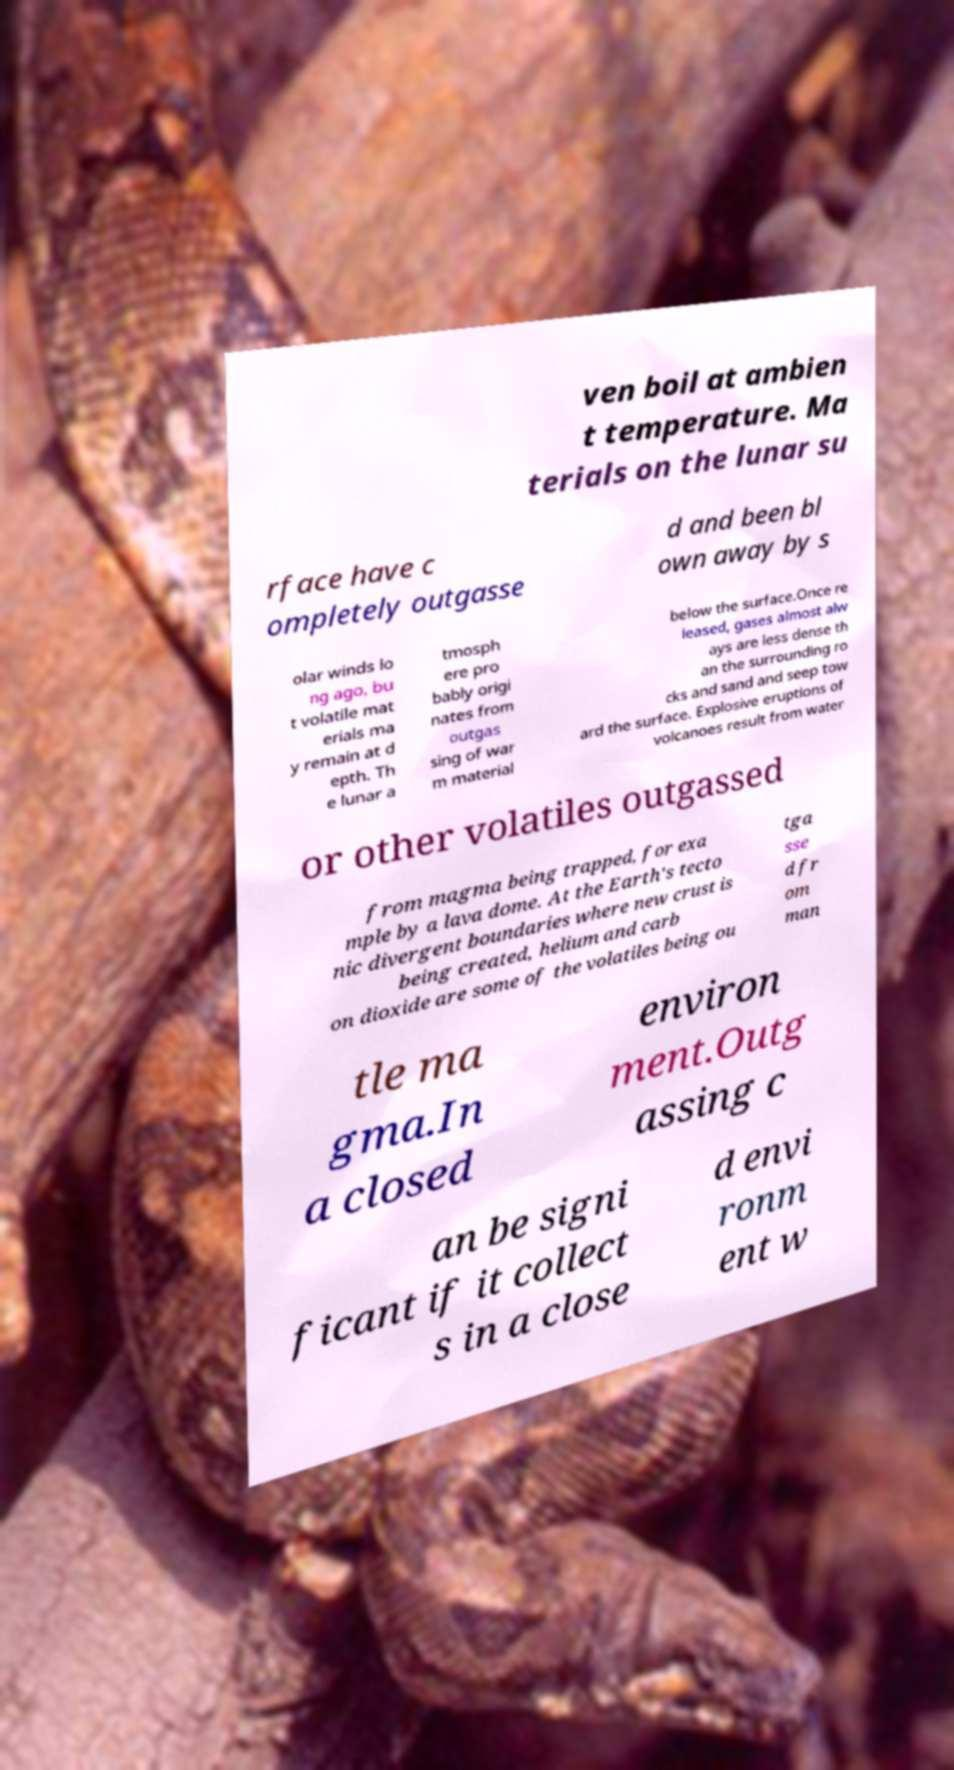I need the written content from this picture converted into text. Can you do that? ven boil at ambien t temperature. Ma terials on the lunar su rface have c ompletely outgasse d and been bl own away by s olar winds lo ng ago, bu t volatile mat erials ma y remain at d epth. Th e lunar a tmosph ere pro bably origi nates from outgas sing of war m material below the surface.Once re leased, gases almost alw ays are less dense th an the surrounding ro cks and sand and seep tow ard the surface. Explosive eruptions of volcanoes result from water or other volatiles outgassed from magma being trapped, for exa mple by a lava dome. At the Earth's tecto nic divergent boundaries where new crust is being created, helium and carb on dioxide are some of the volatiles being ou tga sse d fr om man tle ma gma.In a closed environ ment.Outg assing c an be signi ficant if it collect s in a close d envi ronm ent w 